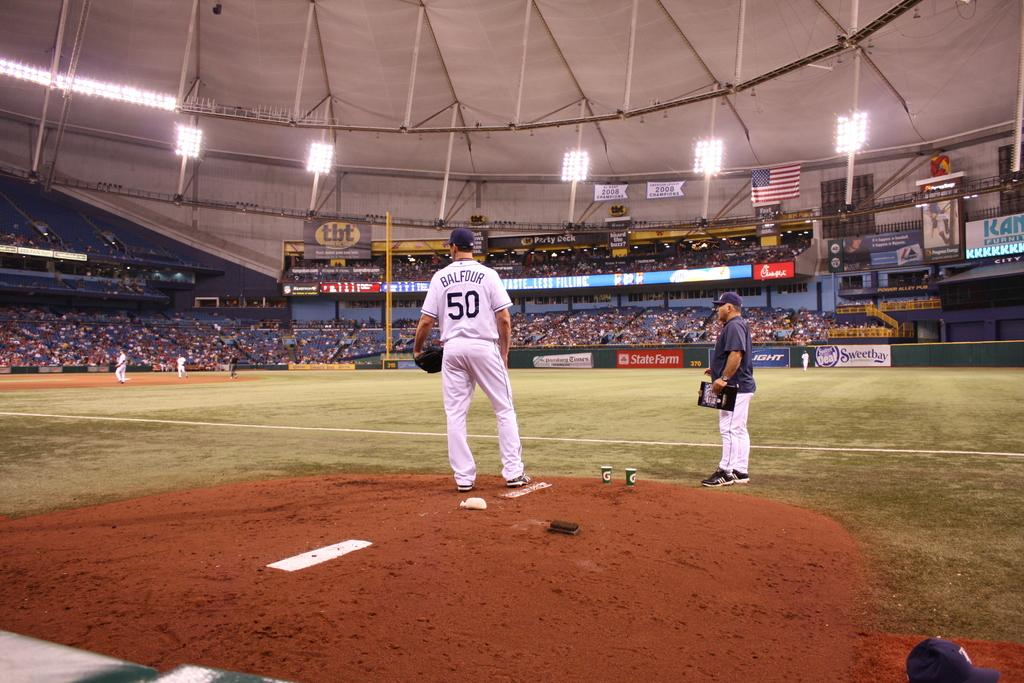<image>
Offer a succinct explanation of the picture presented. the baseball player standing in the ground who wear the white jersey printed as BALFOUR and the number 50 